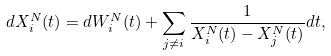Convert formula to latex. <formula><loc_0><loc_0><loc_500><loc_500>d X ^ { N } _ { i } ( t ) = d W ^ { N } _ { i } ( t ) + \sum _ { j \ne i } \frac { 1 } { X ^ { N } _ { i } ( t ) - X ^ { N } _ { j } ( t ) } d t ,</formula> 